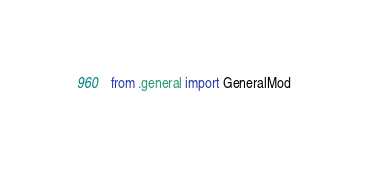Convert code to text. <code><loc_0><loc_0><loc_500><loc_500><_Python_>from .general import GeneralMod</code> 